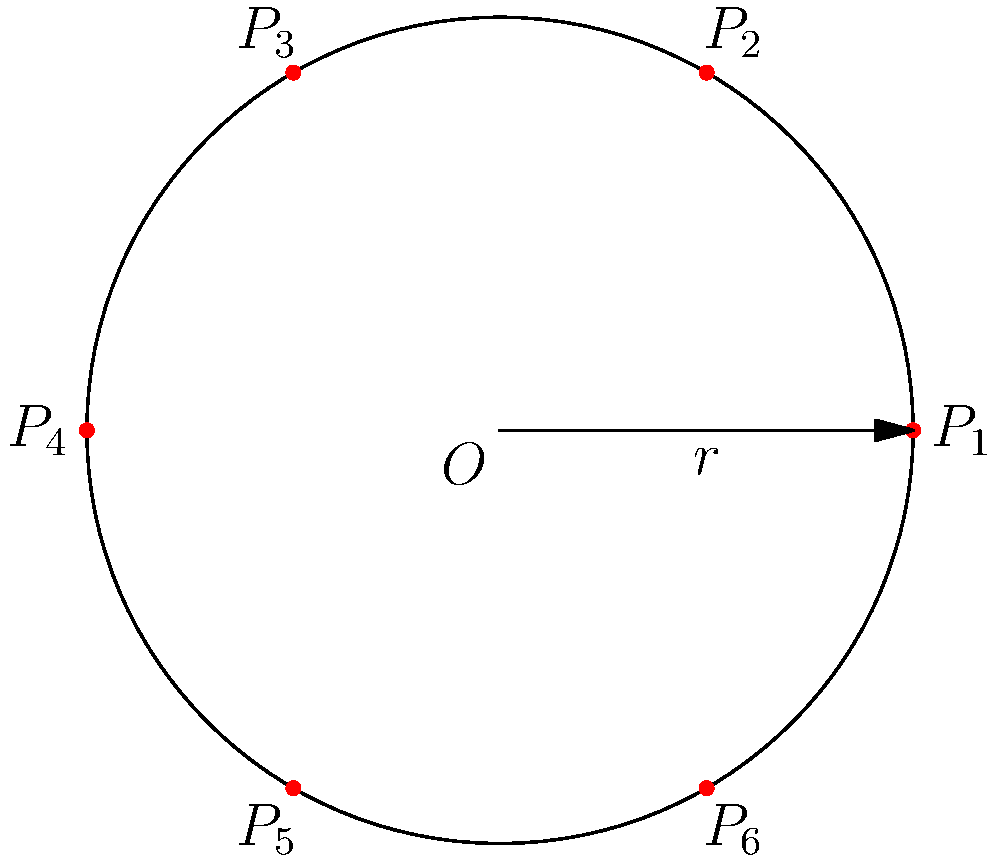A circular wound dressing with radius $r$ has six pressure points ($P_1$ to $P_6$) evenly distributed around its circumference. If the polar coordinates of $P_1$ are $(r, 0)$, what are the polar coordinates of $P_4$? To solve this problem, let's follow these steps:

1) In a circle, there are 360° or $2\pi$ radians.

2) With 6 evenly distributed points, each point is separated by $\frac{2\pi}{6} = \frac{\pi}{3}$ radians or 60°.

3) $P_1$ is at $(r, 0)$, which is the starting point.

4) To get to $P_4$, we need to move 3 positions counterclockwise from $P_1$.

5) This means we need to rotate by $3 \times \frac{\pi}{3} = \pi$ radians or 180°.

6) In polar coordinates, an angle of $\pi$ radians represents the point directly opposite the starting point on the circle.

7) The radius remains unchanged at $r$.

Therefore, the polar coordinates of $P_4$ are $(r, \pi)$.
Answer: $(r, \pi)$ 